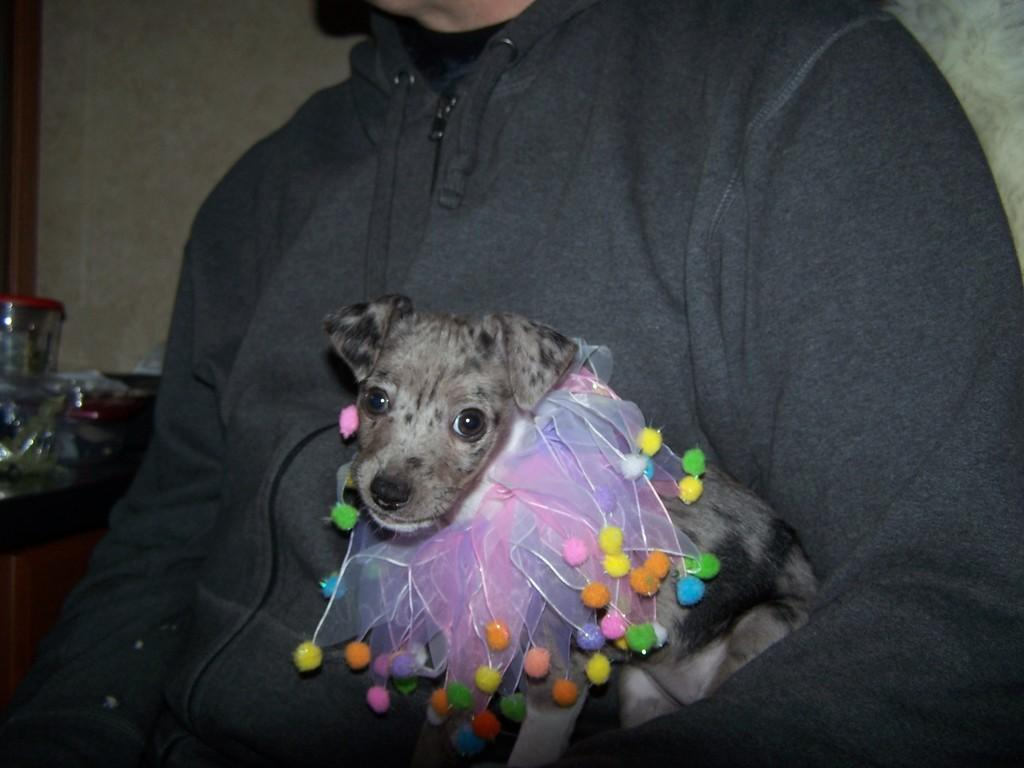What can be seen in the image? There is a person in the image. Can you describe the person's appearance? The person's face is not visible, but they are wearing clothes. What is the person holding in the image? The person is holding a dog. What is visible in the background of the image? There is a wall in the background of the image. What type of dress is the doctor wearing in the aftermath of the event? There is no dress, doctor, or event present in the image. The image features a person holding a dog, with no mention of a dress, doctor, or any event. 